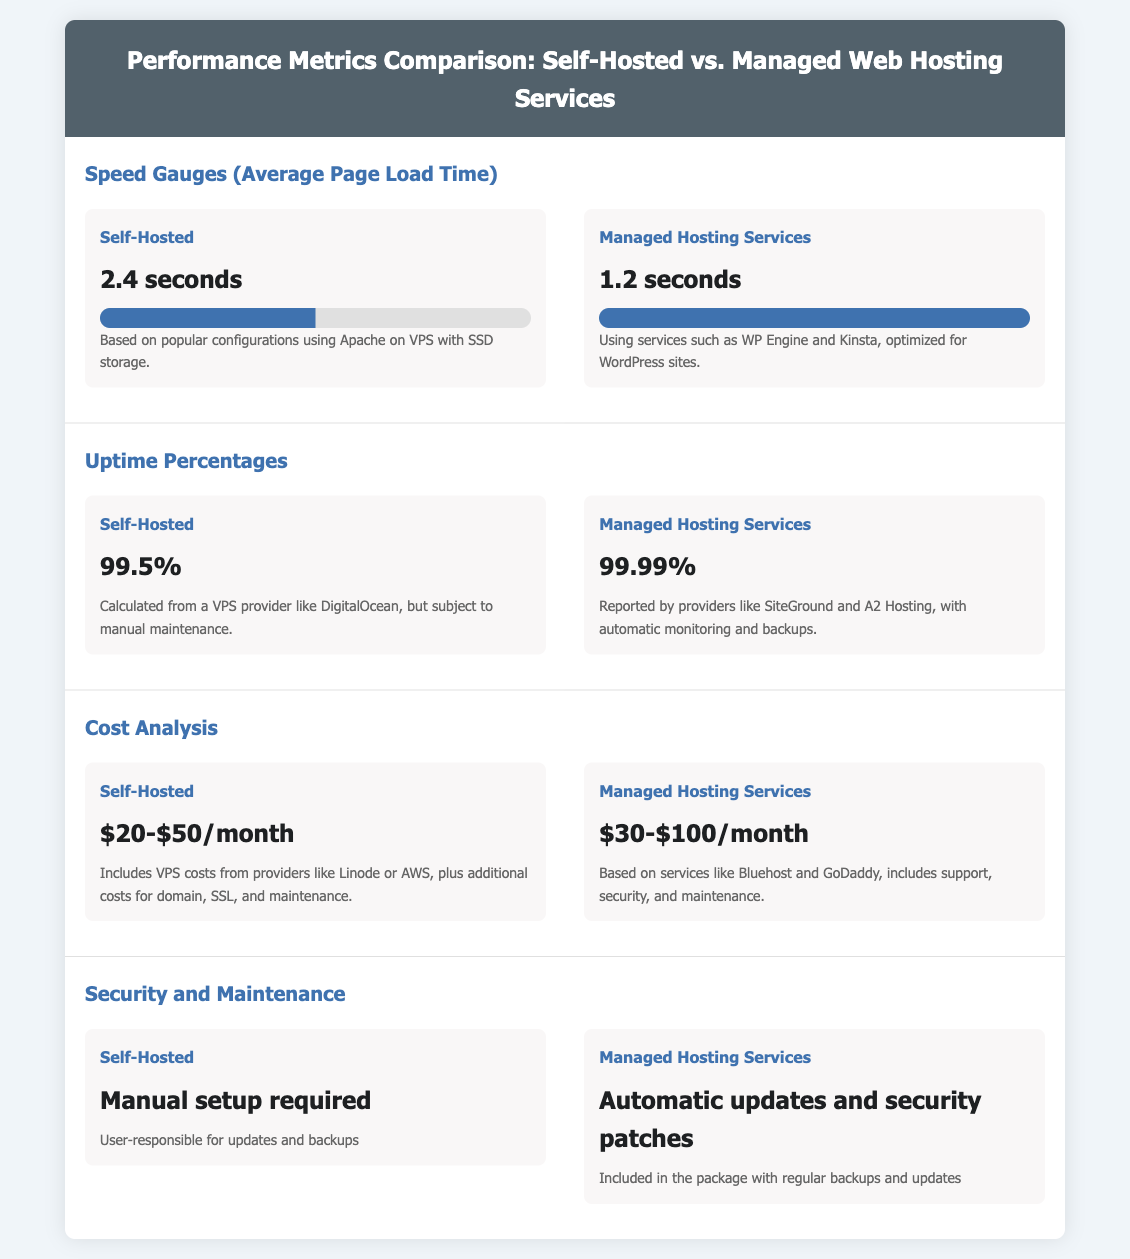What is the average page load time for self-hosted services? The average page load time for self-hosted services is specified in the document as 2.4 seconds.
Answer: 2.4 seconds What is the uptime percentage for managed hosting services? The document states that the uptime percentage for managed hosting services is 99.99%.
Answer: 99.99% How much do managed hosting services cost per month? The document indicates the cost for managed hosting services ranges from $30 to $100 per month.
Answer: $30-$100/month What is the descriptive difference in maintenance between self-hosted and managed hosting services? The document describes self-hosted as requiring manual setup and user-responsibility for updates and backups, while managed hosting services provide automatic updates and backups.
Answer: Manual setup vs. Automatic updates Which hosting service has better page load speed? Comparing the page load speed outlined in the document, managed hosting services have a better speed at 1.2 seconds compared to self-hosted at 2.4 seconds.
Answer: Managed hosting services What is the average page load time for managed hosting services? The document specifies the average page load time for managed hosting services is 1.2 seconds.
Answer: 1.2 seconds What percentage of uptime is typical for self-hosted services? According to the document, self-hosted services typically have an uptime percentage of 99.5%.
Answer: 99.5% What includes security features in managed hosting services? The document notes that managed hosting services include automatic updates and security patches as part of their package.
Answer: Automatic updates and security patches What types of services are identified as managed hosting in the document? The document highlights services like WP Engine, Kinsta, SiteGround, and A2 Hosting as examples of managed hosting services.
Answer: WP Engine, Kinsta, SiteGround, A2 Hosting 